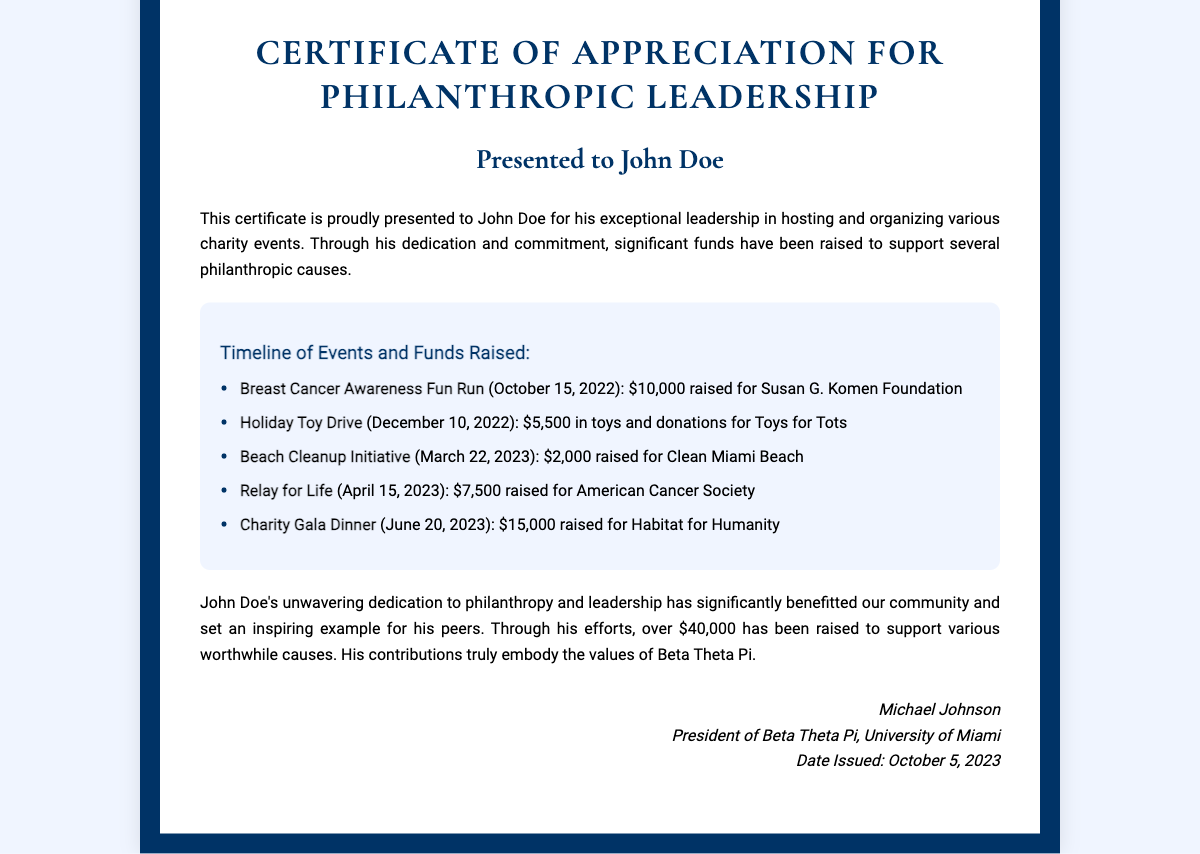What is the title of the certificate? The title of the certificate is presented at the top of the document, which is "Certificate of Appreciation for Philanthropic Leadership."
Answer: Certificate of Appreciation for Philanthropic Leadership Who is the certificate presented to? The certificate states the name of the recipient, which is mentioned directly under the title.
Answer: John Doe How much was raised in the Holiday Toy Drive? The exact amount raised during the Holiday Toy Drive is specified in the timeline section of the certificate.
Answer: $5,500 What event took place on April 15, 2023? The timeline lists the events in chronological order, indicating the event that corresponds to this date.
Answer: Relay for Life What is the total amount raised from all events? The total amount includes all individual amounts listed in the timeline, which sums to over $40,000.
Answer: Over $40,000 Who issued this certificate? The signature at the bottom of the certificate indicates the name of the person who issued it.
Answer: Michael Johnson When was the certificate issued? The date issued is noted in the signature section of the document.
Answer: October 5, 2023 What organization does John Doe represent? The certificate mentions a specific fraternity at the University of Miami associated with the recipient.
Answer: Beta Theta Pi What action is highlighted by John Doe in the document? The document focuses on John Doe's involvement in charity initiatives and events, specifically his leadership in hosting them.
Answer: Philanthropic Leadership 